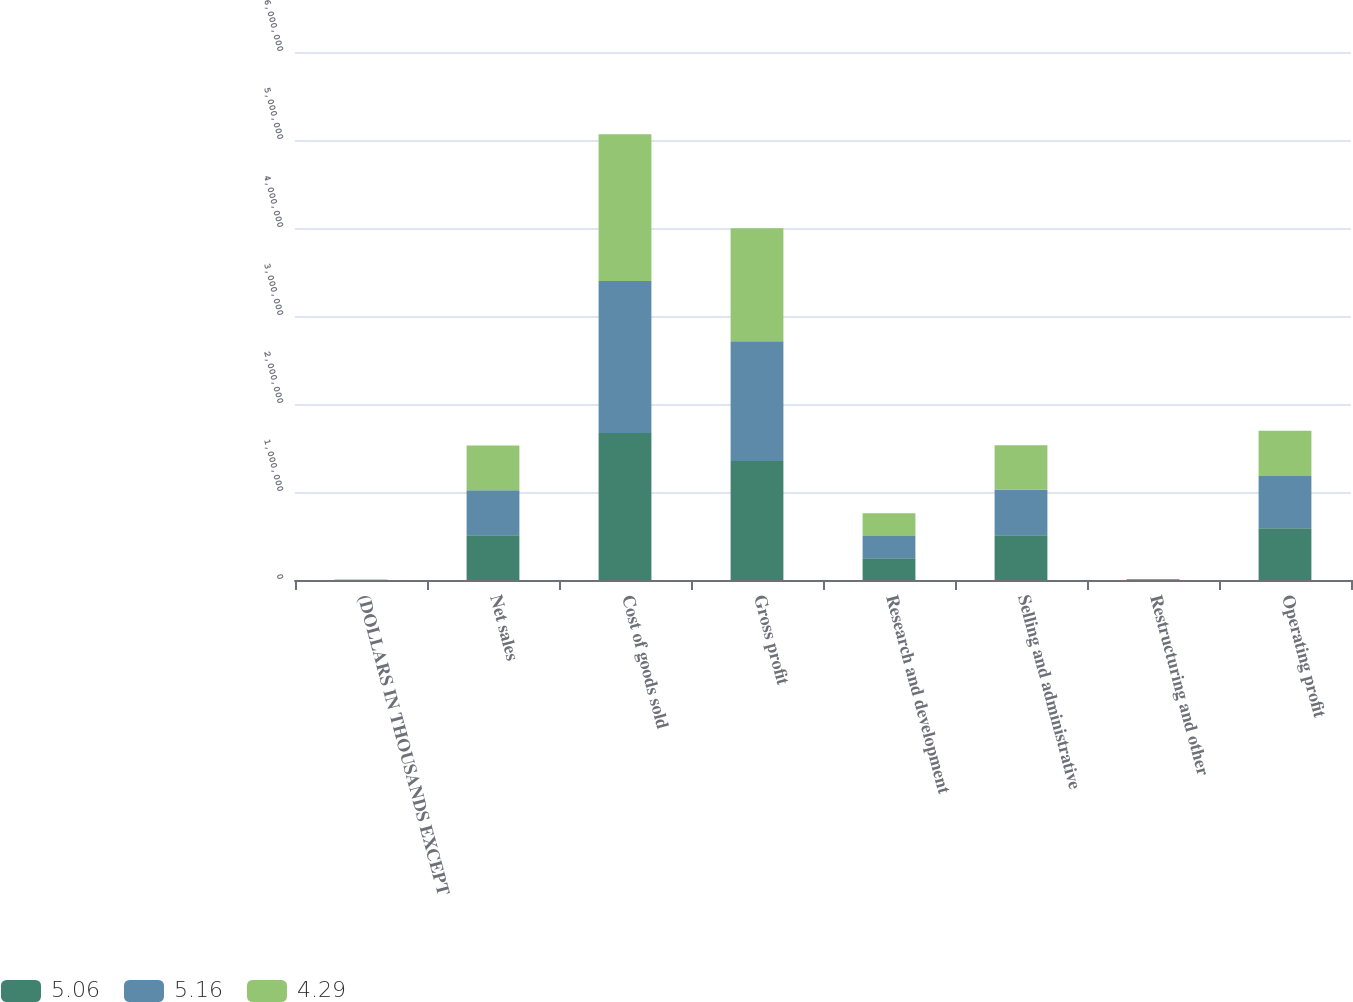Convert chart. <chart><loc_0><loc_0><loc_500><loc_500><stacked_bar_chart><ecel><fcel>(DOLLARS IN THOUSANDS EXCEPT<fcel>Net sales<fcel>Cost of goods sold<fcel>Gross profit<fcel>Research and development<fcel>Selling and administrative<fcel>Restructuring and other<fcel>Operating profit<nl><fcel>5.06<fcel>2015<fcel>509557<fcel>1.67159e+06<fcel>1.3516e+06<fcel>246101<fcel>509557<fcel>7594<fcel>588347<nl><fcel>5.16<fcel>2014<fcel>509557<fcel>1.72638e+06<fcel>1.36215e+06<fcel>253640<fcel>514891<fcel>1298<fcel>592321<nl><fcel>4.29<fcel>2013<fcel>509557<fcel>1.66869e+06<fcel>1.2842e+06<fcel>259838<fcel>505877<fcel>2151<fcel>516339<nl></chart> 